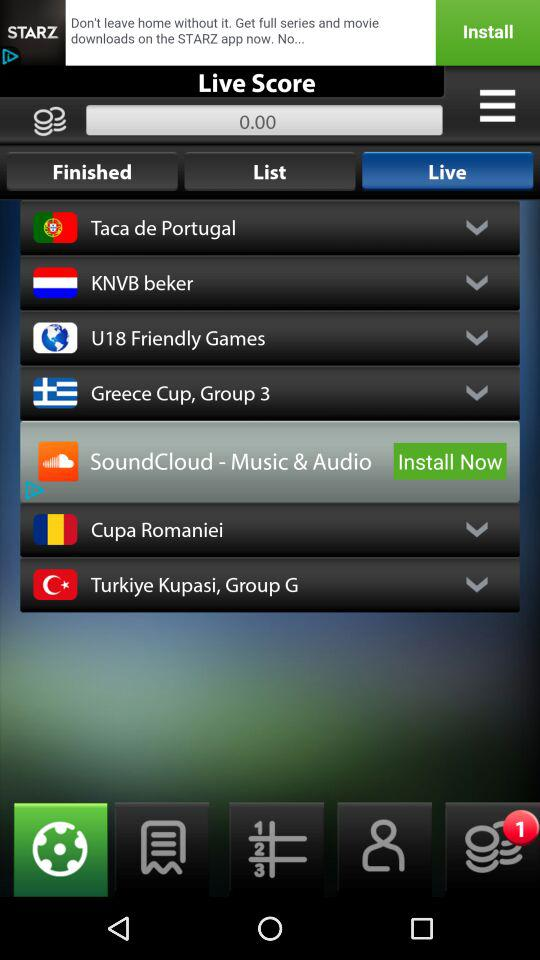What is the score shown on the screen? The score is 0. 